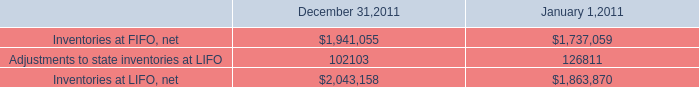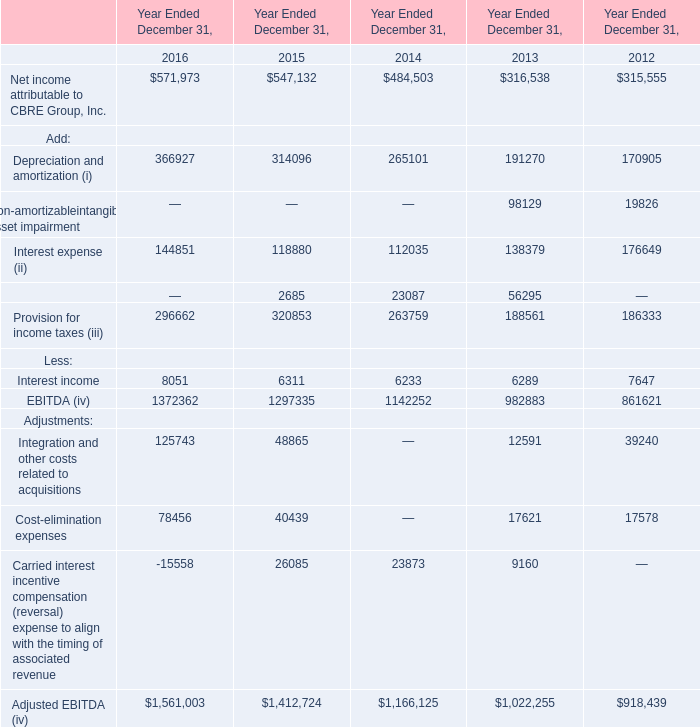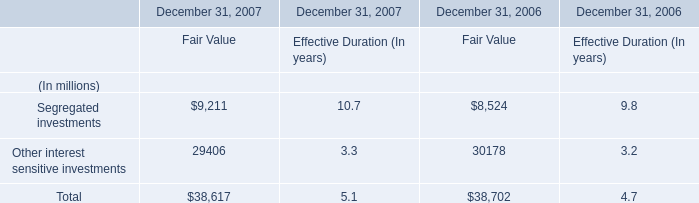What's the growth rate of Depreciation and amortization (i) in 2016? 
Computations: ((366927 - 314096) / 314096)
Answer: 0.1682. 